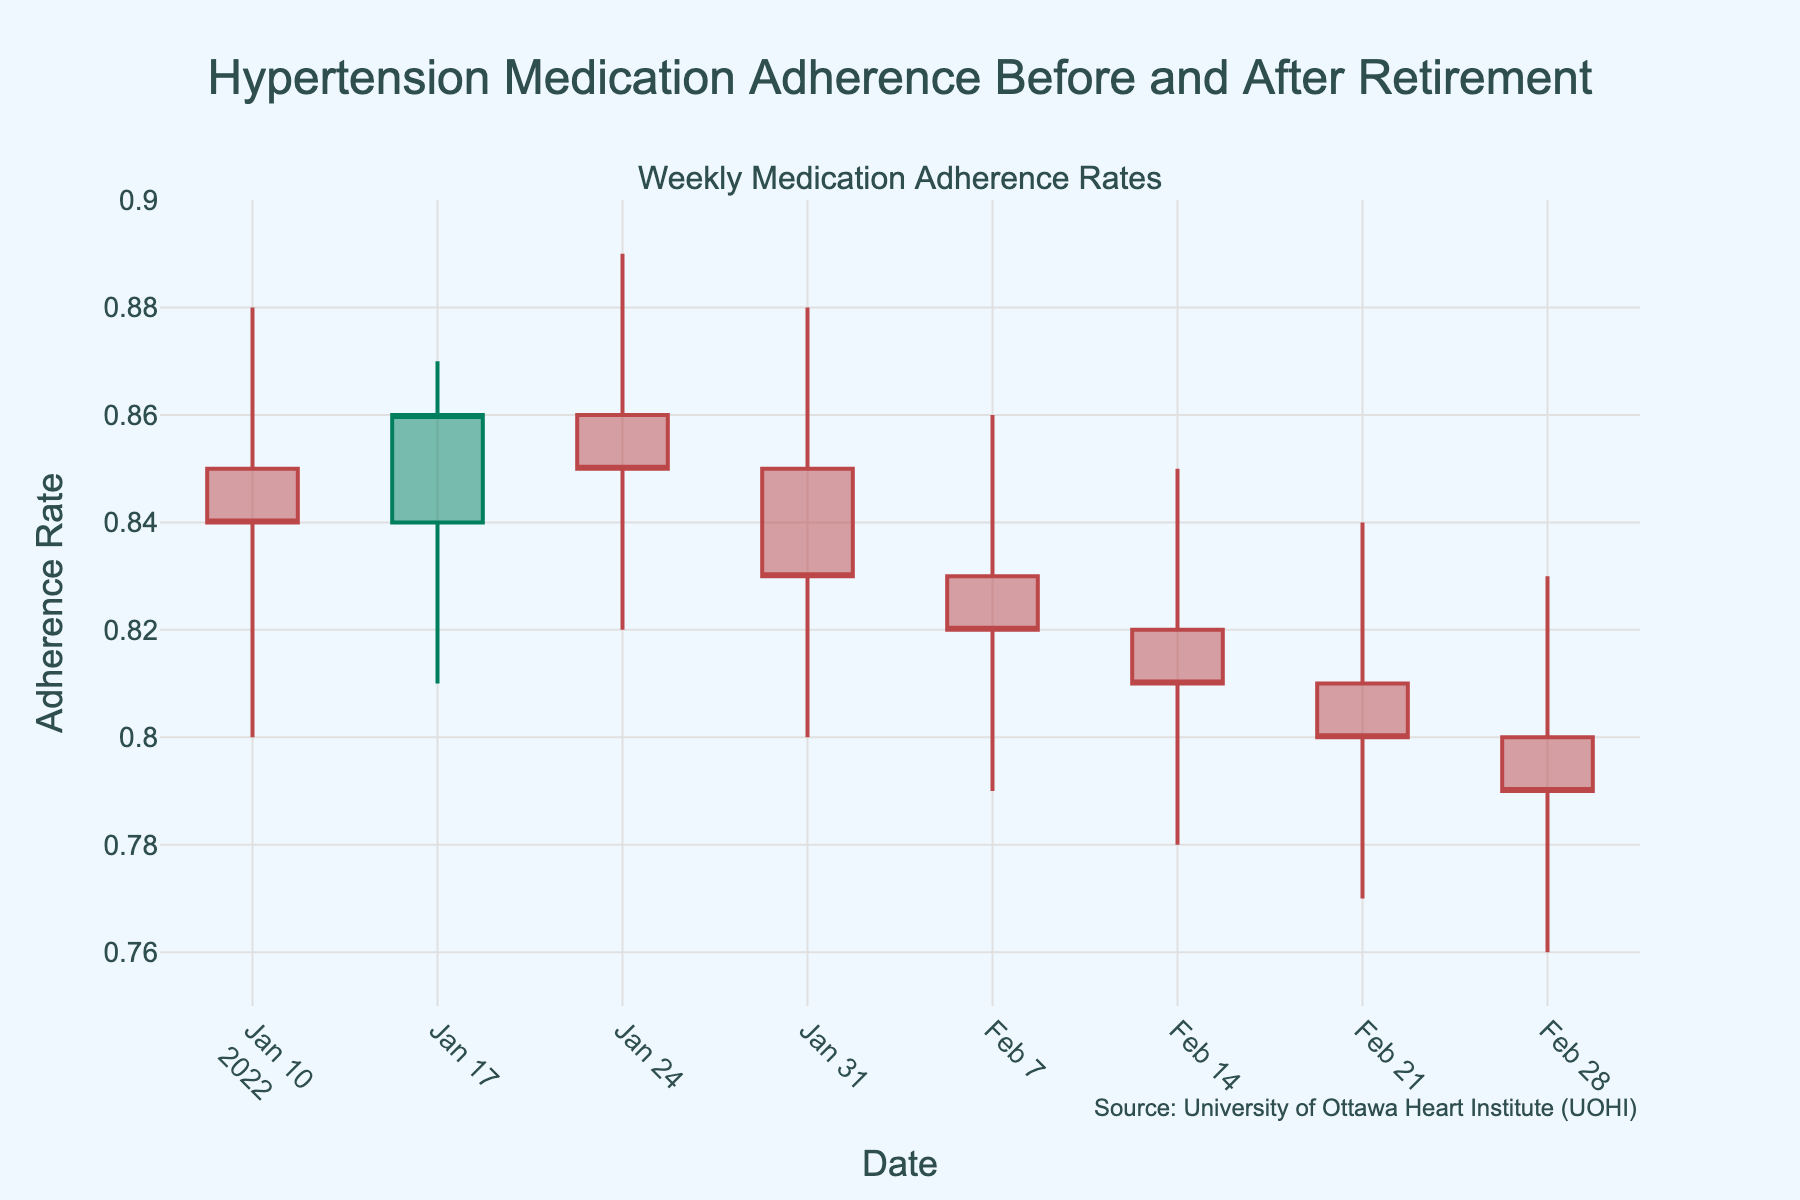What is the title of the candlestick plot? The title of the candlestick plot is positioned at the top center of the figure. It reads "Hypertension Medication Adherence Before and After Retirement".
Answer: Hypertension Medication Adherence Before and After Retirement What color is used to represent increasing adherence rates? In a candlestick plot, the color of the increasing bars generally shows a positive trend. The color used for increasing adherence rates in this plot is a shade of green.
Answer: Green On which date was the medication adherence rate highest during the selected period? Looking at the candlestick representing each week, the highest peak adherence rate is observed. This corresponds to the week of January 24, 2022, with a peak value of 0.89.
Answer: January 24, 2022 What is the lowest medication adherence rate recorded in the dataset? By examining the lowest points in the candlesticks, the minimum adherence rate is observed as 0.76, occurring in the week of February 28, 2022.
Answer: 0.76 What is the range of adherence rates for the week of January 31, 2022? For January 31, 2022, observe the highest (0.88) and the lowest (0.80) adherence rates in the candlestick. Subtract the lowest from the highest: 0.88 - 0.80 = 0.08.
Answer: 0.08 How does the adherence rate change from the week of January 10 to January 17, 2022? Compare the closing adherence rates of January 10 (0.84) and January 17 (0.86). Adherence increased by 0.02.
Answer: Increased by 0.02 Which week shows a decreasing trend in medication adherence rate with the highest opening value? In a candlestick plot, a decreasing trend is indicated when the close value is lower than the open value. The week of January 31, 2022, had an opening adherence rate of 0.85, which is the highest for a decreasing trend week.
Answer: January 31, 2022 What is the average opening adherence rate for the weeks provided? Sum the opening adherence rates: 0.85 + 0.84 + 0.86 + 0.85 + 0.83 + 0.82 + 0.81 + 0.80 = 6.76. Divide by the number of weeks (8): 6.76 / 8 = 0.845.
Answer: 0.845 Considering the weeks when adherence rates closed lower than they opened, what is the total decrease over those weeks? Identify weeks with decreasing trends and sum the differences: (0.85-0.84) + (0.85-0.83) + (0.83-0.82) + (0.82-0.81) + (0.81-0.80) = 0.01 + 0.02 + 0.01 + 0.01 + 0.01 = 0.06.
Answer: 0.06 What is the trend in medication adherence in the whole period? Analyze the entire timeframe by comparing the opening adherence rate at the start (0.85 on January 10) to the closing rate at the end (0.79 on February 28). This shows an overall decreasing trend.
Answer: Decreasing 